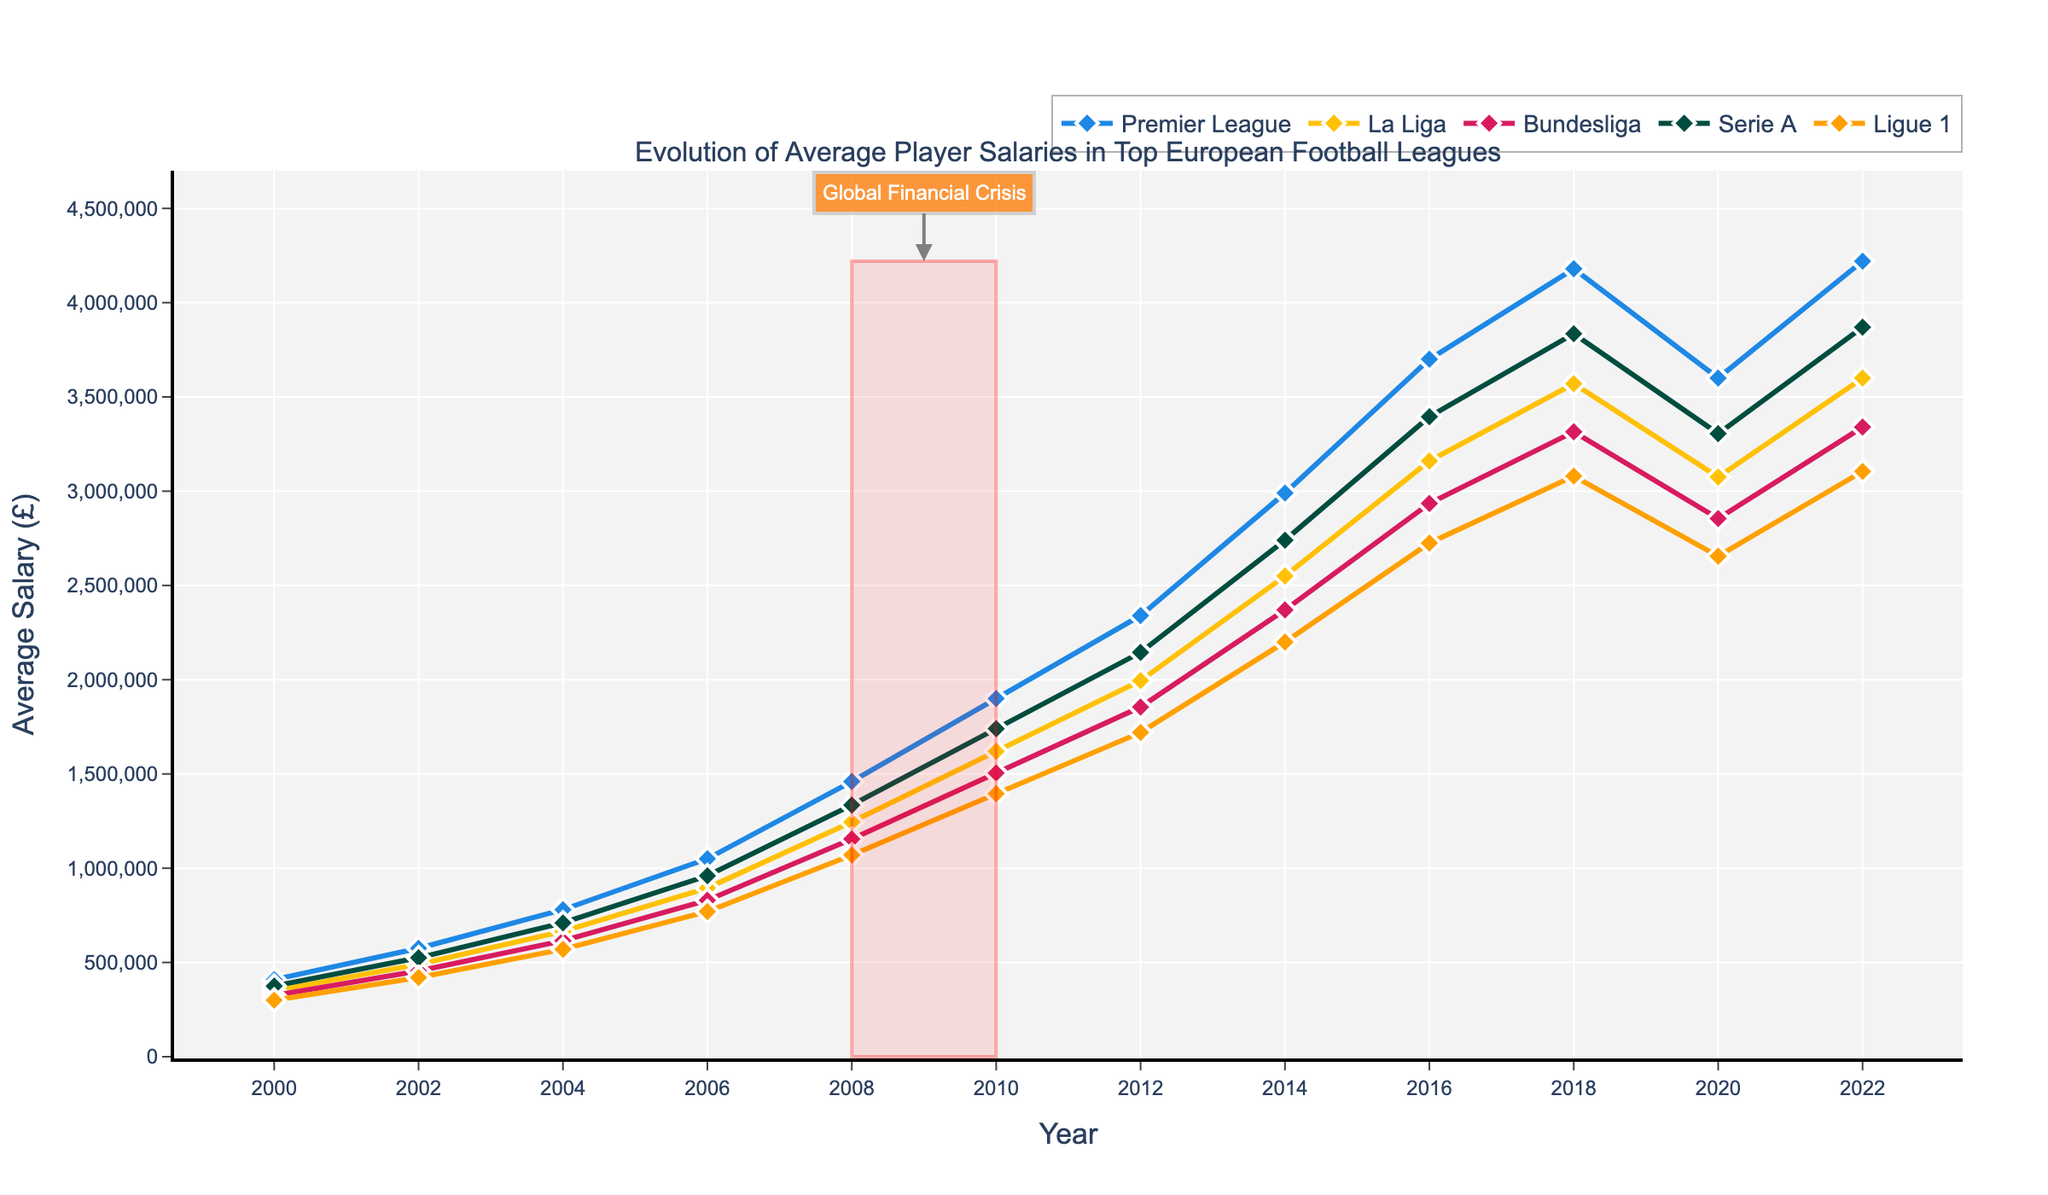What's the highest average player salary across all leagues in 2022, and which league does it belong to? We look at the plot and see which line reaches the highest point in the year 2022. The Premier League’s salary of £4,220,000 is the highest.
Answer: £4,220,000, Premier League Which league had the highest increase in average player salary from 2000 to 2022? We calculate the difference in player salaries from 2000 to 2022 for each league and compare these differences. Premier League had the highest increase: £4,220,000 (2022) - £409,000 (2000) = £3,811,000.
Answer: Premier League During which time period did the average player salaries in Serie A see a decline? We observe the line for Serie A and find the years where the slope of the line goes downward. From 2018 to 2020, the average salary decreased from £3,835,000 to £3,305,000.
Answer: 2018 to 2020 What is the average player salary in Ligue 1 during the Global Financial Crisis marked in the figure? The marked area indicates the years 2008 to 2010. We take the values for Ligue 1 in these years and calculate the average: (£1,070,000 (2008) + £1,395,000 (2010)) / 2 = £1,232,500.
Answer: £1,232,500 Compare the average player salary in Bundesliga and La Liga in 2006. Which one is higher and by how much? Look at the values for 2006 for both leagues. Bundesliga: £830,000, La Liga: £895,000. La Liga's salary is higher. Difference = £895,000 - £830,000 = £65,000.
Answer: La Liga, £65,000 In which year did the Premier League’s average player salary surpass £1,000,000? Find the point where the Premier League line crosses the £1,000,000 mark. This happens between 2006 and 2008. As 2006 shows £1,050,000, 2006 is the year.
Answer: 2006 How did the average player salaries in La Liga evolve between 2010 and 2022? Observe the La Liga line from 2010 to 2022. In 2010, it was £1,620,000. It peaks at £3,570,000 in 2018, then slightly increases to £3,600,000 in 2022.
Answer: Increased overall with a peak in 2018 Identify the league with the most consistent growth in average player salary from 2000 to 2018. Find the league with the most steady and linear growth line between these years by visually inspecting the figure. The Premier League shows a stable upward trend with no sharp declines from 2000 to 2018.
Answer: Premier League Between 2018 and 2020, which leagues experienced a decrease in average player salaries, and by how much? Identify the downward slopes for each league in this period, and calculate the differences. Premier League: £4,180,000 (2018) - £3,600,000 (2020) = £580,000. La Liga: £3,570,000 (2018) - £3,075,000 (2020) = £495,000. Bundesliga: £3,315,000 (2018) - £2,855,000 (2020) = £460,000. Serie A: £3,835,000 (2018) - £3,305,000 (2020) = £530,000. Ligue 1: £3,080,000 (2018) - £2,655,000 (2020) = £425,000.
Answer: All five leagues, with Premier League having the largest decrease of £580,000 Which league had the slowest growth in average player salary between 2000 and 2022? Calculate the difference in average player salary for each league between 2000 and 2022 and identify the smallest increase. Ligue 1: £3,105,000 - £300,000 = £2,805,000.
Answer: Ligue 1 